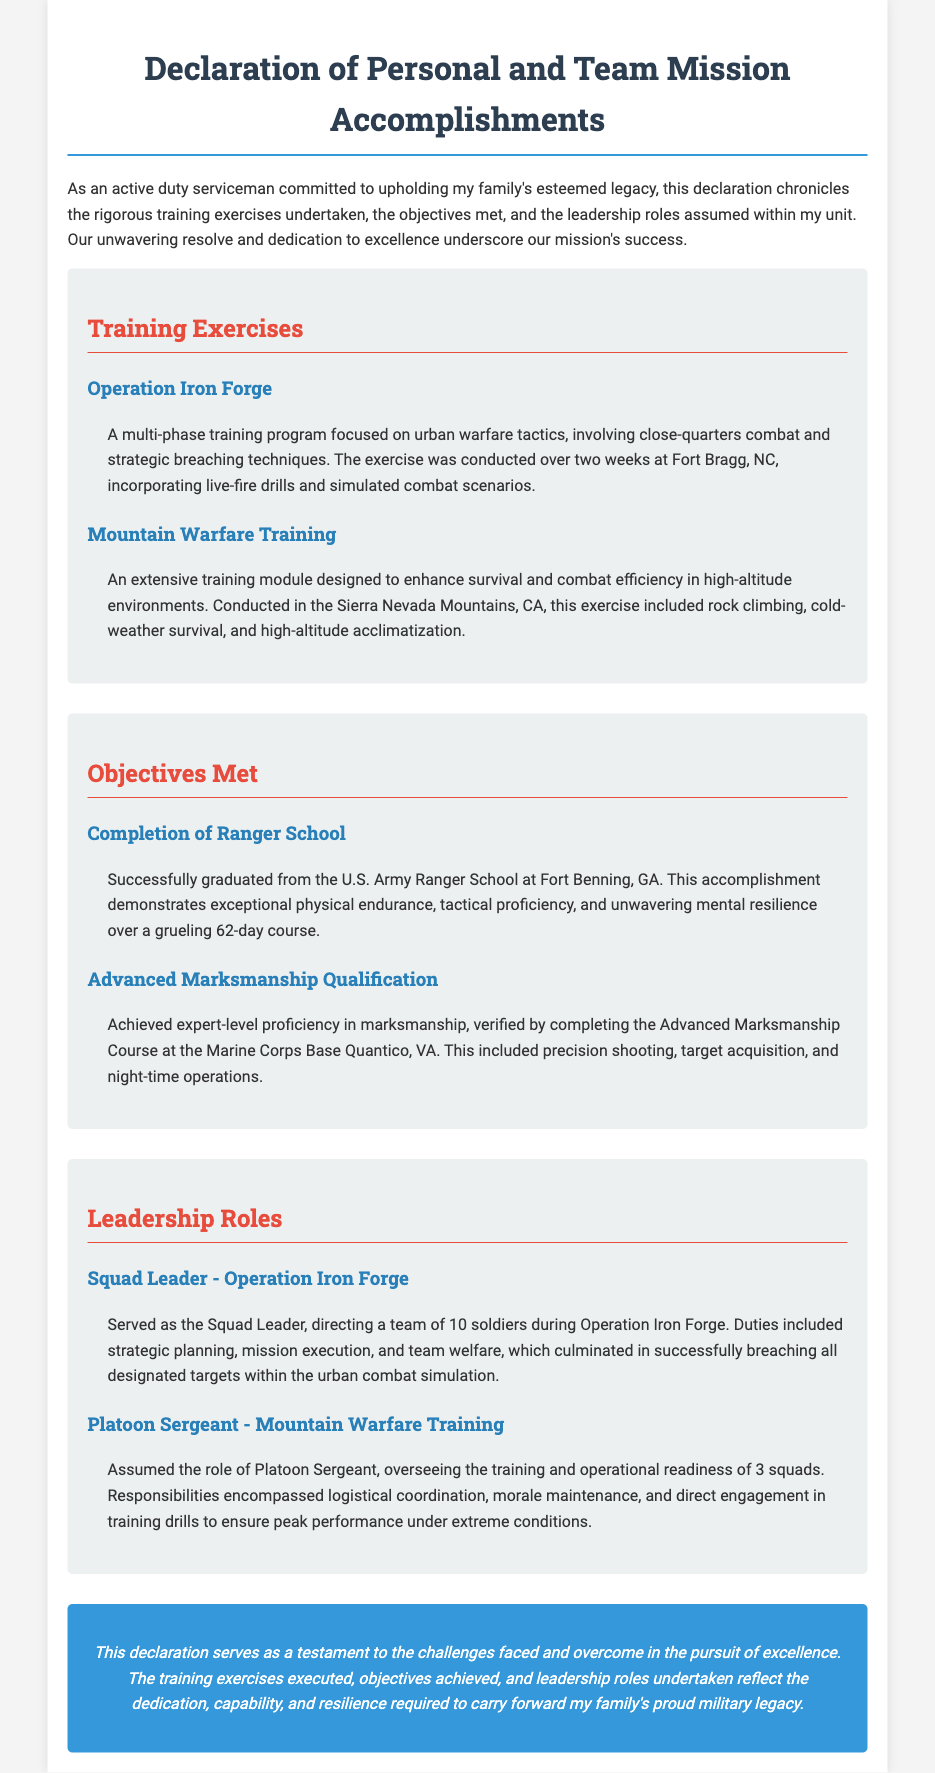What is the title of the document? The title is prominently displayed at the top of the document, indicating the subject matter it covers.
Answer: Declaration of Personal and Team Mission Accomplishments How long was Operation Iron Forge conducted? The duration of Operation Iron Forge is specified in the document as two weeks.
Answer: two weeks What school did the serviceman graduate from? The document states that the serviceman successfully graduated from a specific military school, highlighting an important achievement.
Answer: U.S. Army Ranger School What was the location of the Advanced Marksmanship Course? The document mentions the specific Marine Corps Base where the course took place, providing context for the training.
Answer: Marine Corps Base Quantico, VA Who served as the Squad Leader during Operation Iron Forge? The document clarifies which role was undertaken by the serviceman in this training exercise, linking responsibilities to achievements.
Answer: Squad Leader What type of environment was the Mountain Warfare Training conducted in? The document describes the environment which gives context to the nature of this specific training exercise.
Answer: high-altitude environments Which leadership role involved overseeing the training of three squads? The document specifies the position related to leadership responsibilities and the number of squads supervised.
Answer: Platoon Sergeant What was one objective achieved according to the document? The document lists specific accomplishments, showcasing the effectiveness and goals reached during training.
Answer: Advanced Marksmanship Qualification What color themes are used in the section headings? The document describes the visual design choices made for highlighting specific sections, which also reflects the overall tone.
Answer: red and blue 